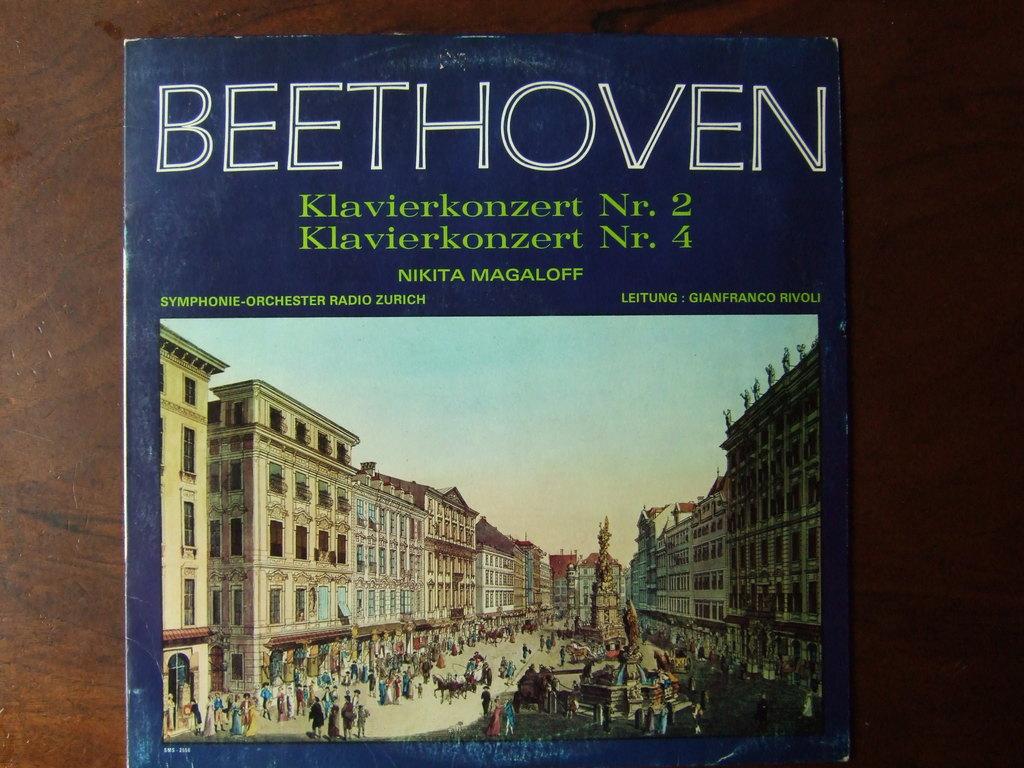What city symphony orchestra was used?
Offer a terse response. Zurich. 